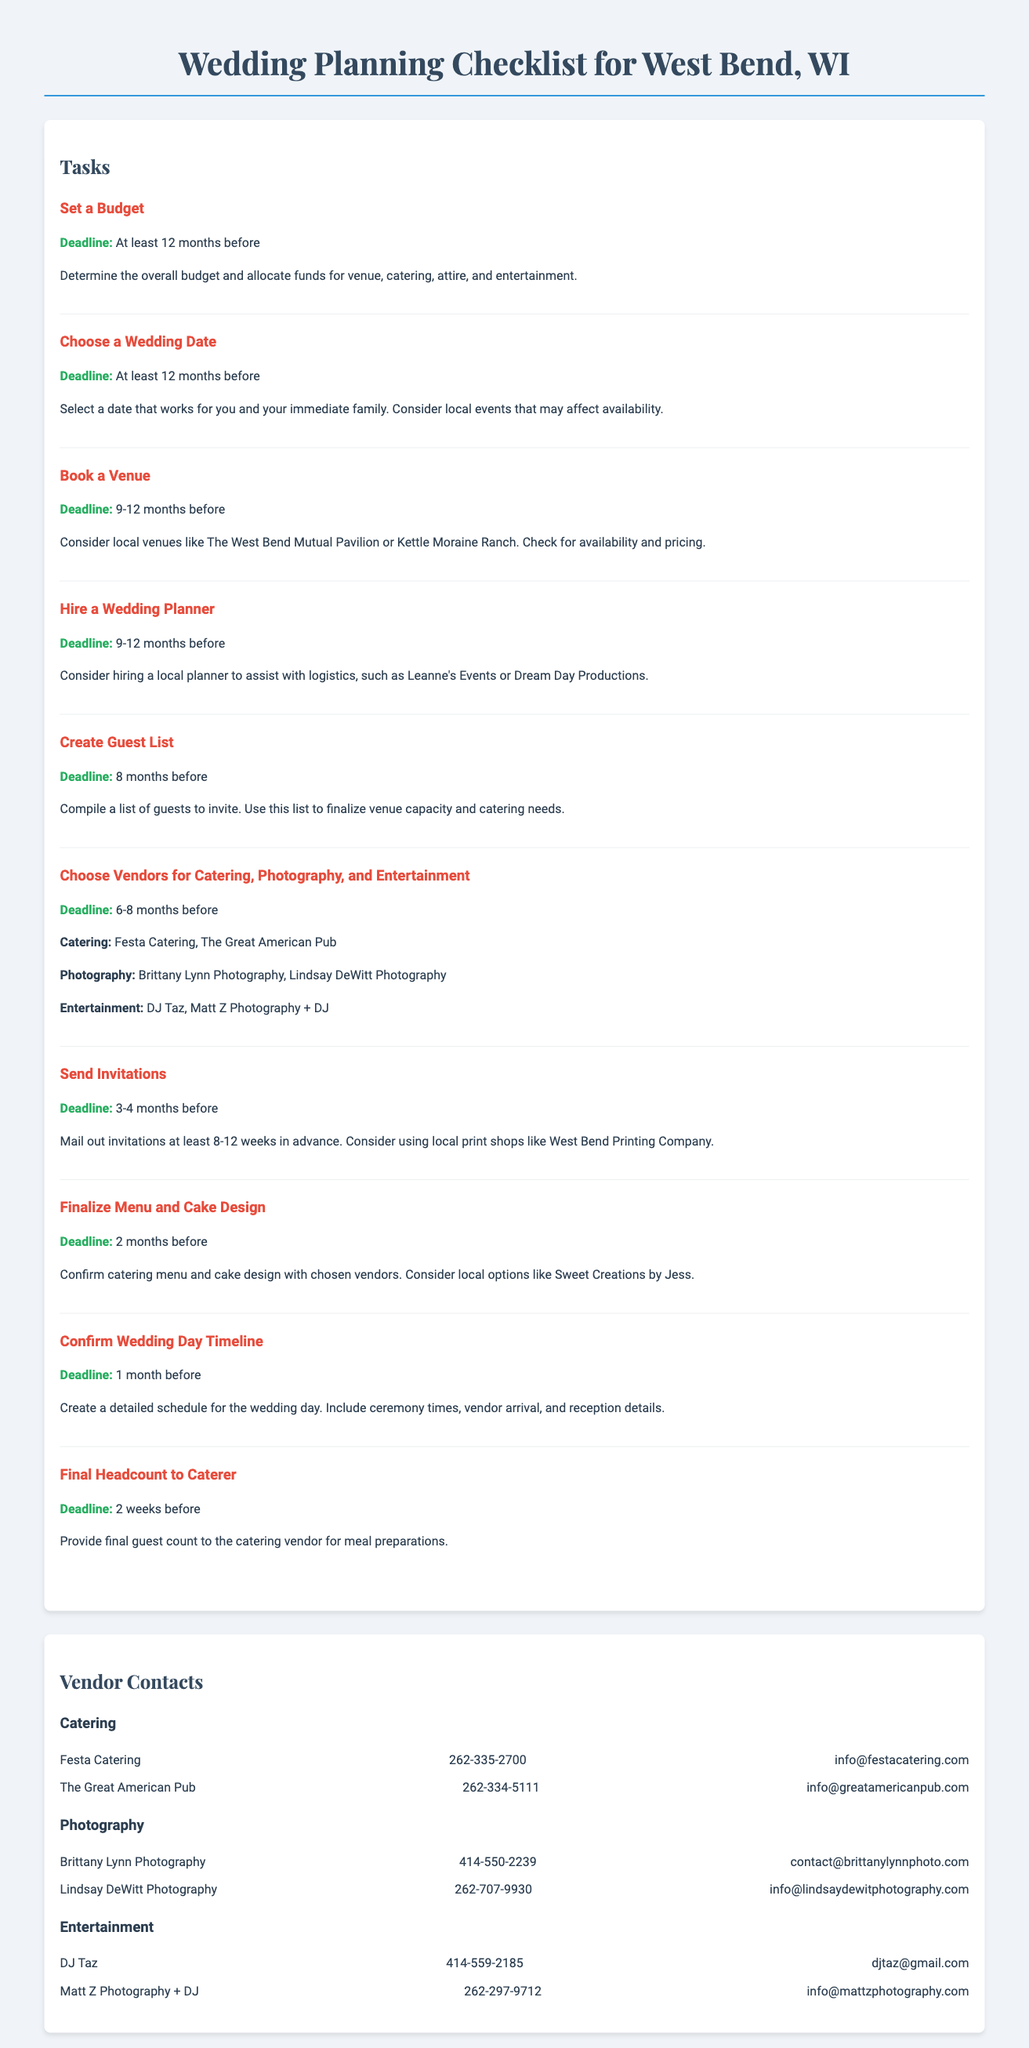What is the first task in the checklist? The first task listed is "Set a Budget," which is a key component of the wedding planning process.
Answer: Set a Budget What is the deadline for choosing a wedding date? The deadline stated for choosing a wedding date is "At least 12 months before."
Answer: At least 12 months before Who are two recommended catering vendors? The document lists Festa Catering and The Great American Pub as catering options.
Answer: Festa Catering, The Great American Pub What is the final headcount deadline for the caterer? According to the checklist, the final headcount should be provided to the caterer "2 weeks before" the wedding.
Answer: 2 weeks before When should invitations be sent? The checklist specifies that invitations should be mailed out "3-4 months before" the wedding date.
Answer: 3-4 months before What vendor type is Brittany Lynn associated with? Brittany Lynn is listed under the photography category, indicating her specialty.
Answer: Photography How many months before should the venue be booked? The checklist indicates that the venue should be booked "9-12 months before" the event.
Answer: 9-12 months before Which task involves confirming the menu and cake design? The task titled "Finalize Menu and Cake Design" involves working with the vendors to confirm details related to food and dessert.
Answer: Finalize Menu and Cake Design What contact information is provided for DJ Taz? The document provides DJ Taz's phone number and email address for contacting him regarding entertainment services.
Answer: 414-559-2185, djtaz@gmail.com 